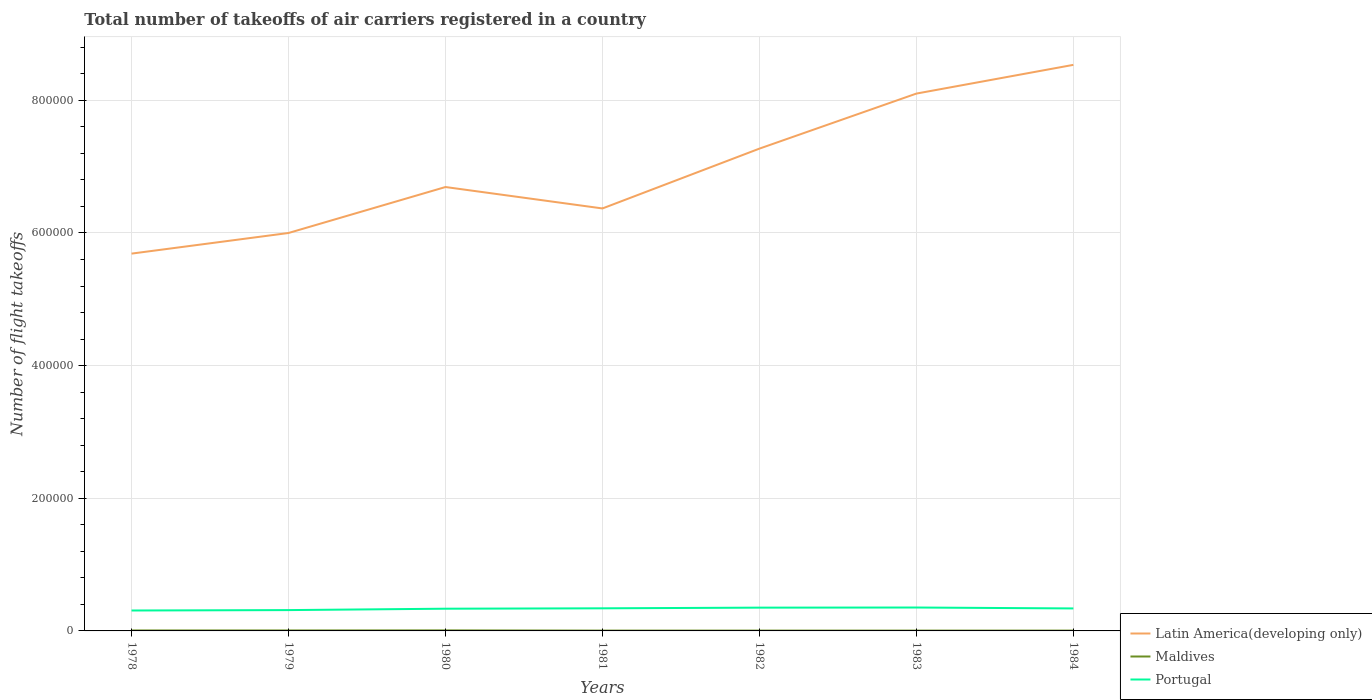Is the number of lines equal to the number of legend labels?
Offer a very short reply. Yes. What is the total total number of flight takeoffs in Portugal in the graph?
Offer a terse response. -600. What is the difference between the highest and the second highest total number of flight takeoffs in Latin America(developing only)?
Provide a short and direct response. 2.85e+05. How many lines are there?
Your answer should be compact. 3. How many years are there in the graph?
Give a very brief answer. 7. What is the difference between two consecutive major ticks on the Y-axis?
Provide a succinct answer. 2.00e+05. Does the graph contain any zero values?
Offer a terse response. No. Does the graph contain grids?
Provide a short and direct response. Yes. Where does the legend appear in the graph?
Provide a short and direct response. Bottom right. What is the title of the graph?
Ensure brevity in your answer.  Total number of takeoffs of air carriers registered in a country. Does "Ukraine" appear as one of the legend labels in the graph?
Your answer should be compact. No. What is the label or title of the X-axis?
Make the answer very short. Years. What is the label or title of the Y-axis?
Offer a terse response. Number of flight takeoffs. What is the Number of flight takeoffs in Latin America(developing only) in 1978?
Keep it short and to the point. 5.69e+05. What is the Number of flight takeoffs of Maldives in 1978?
Ensure brevity in your answer.  700. What is the Number of flight takeoffs of Portugal in 1978?
Keep it short and to the point. 3.08e+04. What is the Number of flight takeoffs in Latin America(developing only) in 1979?
Provide a short and direct response. 6.00e+05. What is the Number of flight takeoffs in Maldives in 1979?
Give a very brief answer. 700. What is the Number of flight takeoffs of Portugal in 1979?
Provide a succinct answer. 3.14e+04. What is the Number of flight takeoffs of Latin America(developing only) in 1980?
Your response must be concise. 6.69e+05. What is the Number of flight takeoffs in Maldives in 1980?
Offer a very short reply. 800. What is the Number of flight takeoffs in Portugal in 1980?
Your answer should be very brief. 3.35e+04. What is the Number of flight takeoffs in Latin America(developing only) in 1981?
Your response must be concise. 6.37e+05. What is the Number of flight takeoffs of Portugal in 1981?
Keep it short and to the point. 3.41e+04. What is the Number of flight takeoffs in Latin America(developing only) in 1982?
Your answer should be very brief. 7.27e+05. What is the Number of flight takeoffs in Portugal in 1982?
Offer a terse response. 3.51e+04. What is the Number of flight takeoffs in Latin America(developing only) in 1983?
Give a very brief answer. 8.10e+05. What is the Number of flight takeoffs of Portugal in 1983?
Make the answer very short. 3.53e+04. What is the Number of flight takeoffs in Latin America(developing only) in 1984?
Provide a short and direct response. 8.54e+05. What is the Number of flight takeoffs in Maldives in 1984?
Provide a succinct answer. 500. What is the Number of flight takeoffs in Portugal in 1984?
Offer a very short reply. 3.39e+04. Across all years, what is the maximum Number of flight takeoffs in Latin America(developing only)?
Your answer should be compact. 8.54e+05. Across all years, what is the maximum Number of flight takeoffs of Maldives?
Ensure brevity in your answer.  800. Across all years, what is the maximum Number of flight takeoffs of Portugal?
Provide a short and direct response. 3.53e+04. Across all years, what is the minimum Number of flight takeoffs of Latin America(developing only)?
Offer a very short reply. 5.69e+05. Across all years, what is the minimum Number of flight takeoffs of Portugal?
Your answer should be very brief. 3.08e+04. What is the total Number of flight takeoffs in Latin America(developing only) in the graph?
Your answer should be very brief. 4.87e+06. What is the total Number of flight takeoffs of Maldives in the graph?
Your answer should be very brief. 4200. What is the total Number of flight takeoffs of Portugal in the graph?
Offer a very short reply. 2.34e+05. What is the difference between the Number of flight takeoffs in Latin America(developing only) in 1978 and that in 1979?
Ensure brevity in your answer.  -3.11e+04. What is the difference between the Number of flight takeoffs in Portugal in 1978 and that in 1979?
Your answer should be compact. -600. What is the difference between the Number of flight takeoffs in Latin America(developing only) in 1978 and that in 1980?
Make the answer very short. -1.00e+05. What is the difference between the Number of flight takeoffs of Maldives in 1978 and that in 1980?
Provide a short and direct response. -100. What is the difference between the Number of flight takeoffs in Portugal in 1978 and that in 1980?
Offer a very short reply. -2700. What is the difference between the Number of flight takeoffs in Latin America(developing only) in 1978 and that in 1981?
Your answer should be very brief. -6.81e+04. What is the difference between the Number of flight takeoffs of Portugal in 1978 and that in 1981?
Give a very brief answer. -3300. What is the difference between the Number of flight takeoffs in Latin America(developing only) in 1978 and that in 1982?
Offer a very short reply. -1.58e+05. What is the difference between the Number of flight takeoffs in Maldives in 1978 and that in 1982?
Make the answer very short. 200. What is the difference between the Number of flight takeoffs of Portugal in 1978 and that in 1982?
Ensure brevity in your answer.  -4300. What is the difference between the Number of flight takeoffs in Latin America(developing only) in 1978 and that in 1983?
Your answer should be compact. -2.41e+05. What is the difference between the Number of flight takeoffs in Maldives in 1978 and that in 1983?
Give a very brief answer. 200. What is the difference between the Number of flight takeoffs of Portugal in 1978 and that in 1983?
Make the answer very short. -4500. What is the difference between the Number of flight takeoffs of Latin America(developing only) in 1978 and that in 1984?
Offer a very short reply. -2.85e+05. What is the difference between the Number of flight takeoffs of Portugal in 1978 and that in 1984?
Provide a short and direct response. -3100. What is the difference between the Number of flight takeoffs of Latin America(developing only) in 1979 and that in 1980?
Give a very brief answer. -6.93e+04. What is the difference between the Number of flight takeoffs in Maldives in 1979 and that in 1980?
Offer a very short reply. -100. What is the difference between the Number of flight takeoffs of Portugal in 1979 and that in 1980?
Give a very brief answer. -2100. What is the difference between the Number of flight takeoffs of Latin America(developing only) in 1979 and that in 1981?
Provide a succinct answer. -3.70e+04. What is the difference between the Number of flight takeoffs of Portugal in 1979 and that in 1981?
Your response must be concise. -2700. What is the difference between the Number of flight takeoffs in Latin America(developing only) in 1979 and that in 1982?
Ensure brevity in your answer.  -1.27e+05. What is the difference between the Number of flight takeoffs of Portugal in 1979 and that in 1982?
Your answer should be very brief. -3700. What is the difference between the Number of flight takeoffs of Latin America(developing only) in 1979 and that in 1983?
Make the answer very short. -2.10e+05. What is the difference between the Number of flight takeoffs of Portugal in 1979 and that in 1983?
Give a very brief answer. -3900. What is the difference between the Number of flight takeoffs of Latin America(developing only) in 1979 and that in 1984?
Your response must be concise. -2.54e+05. What is the difference between the Number of flight takeoffs of Portugal in 1979 and that in 1984?
Ensure brevity in your answer.  -2500. What is the difference between the Number of flight takeoffs in Latin America(developing only) in 1980 and that in 1981?
Provide a succinct answer. 3.23e+04. What is the difference between the Number of flight takeoffs of Maldives in 1980 and that in 1981?
Offer a very short reply. 300. What is the difference between the Number of flight takeoffs of Portugal in 1980 and that in 1981?
Provide a succinct answer. -600. What is the difference between the Number of flight takeoffs of Latin America(developing only) in 1980 and that in 1982?
Your answer should be very brief. -5.79e+04. What is the difference between the Number of flight takeoffs in Maldives in 1980 and that in 1982?
Provide a short and direct response. 300. What is the difference between the Number of flight takeoffs of Portugal in 1980 and that in 1982?
Offer a terse response. -1600. What is the difference between the Number of flight takeoffs in Latin America(developing only) in 1980 and that in 1983?
Offer a terse response. -1.41e+05. What is the difference between the Number of flight takeoffs in Maldives in 1980 and that in 1983?
Give a very brief answer. 300. What is the difference between the Number of flight takeoffs in Portugal in 1980 and that in 1983?
Offer a terse response. -1800. What is the difference between the Number of flight takeoffs of Latin America(developing only) in 1980 and that in 1984?
Provide a succinct answer. -1.84e+05. What is the difference between the Number of flight takeoffs in Maldives in 1980 and that in 1984?
Make the answer very short. 300. What is the difference between the Number of flight takeoffs of Portugal in 1980 and that in 1984?
Give a very brief answer. -400. What is the difference between the Number of flight takeoffs in Latin America(developing only) in 1981 and that in 1982?
Provide a succinct answer. -9.02e+04. What is the difference between the Number of flight takeoffs of Portugal in 1981 and that in 1982?
Your response must be concise. -1000. What is the difference between the Number of flight takeoffs of Latin America(developing only) in 1981 and that in 1983?
Ensure brevity in your answer.  -1.73e+05. What is the difference between the Number of flight takeoffs in Maldives in 1981 and that in 1983?
Your answer should be very brief. 0. What is the difference between the Number of flight takeoffs of Portugal in 1981 and that in 1983?
Provide a short and direct response. -1200. What is the difference between the Number of flight takeoffs of Latin America(developing only) in 1981 and that in 1984?
Provide a short and direct response. -2.16e+05. What is the difference between the Number of flight takeoffs of Maldives in 1981 and that in 1984?
Ensure brevity in your answer.  0. What is the difference between the Number of flight takeoffs of Latin America(developing only) in 1982 and that in 1983?
Your answer should be very brief. -8.30e+04. What is the difference between the Number of flight takeoffs of Portugal in 1982 and that in 1983?
Keep it short and to the point. -200. What is the difference between the Number of flight takeoffs in Latin America(developing only) in 1982 and that in 1984?
Make the answer very short. -1.26e+05. What is the difference between the Number of flight takeoffs in Portugal in 1982 and that in 1984?
Ensure brevity in your answer.  1200. What is the difference between the Number of flight takeoffs in Latin America(developing only) in 1983 and that in 1984?
Your answer should be compact. -4.33e+04. What is the difference between the Number of flight takeoffs in Maldives in 1983 and that in 1984?
Offer a terse response. 0. What is the difference between the Number of flight takeoffs in Portugal in 1983 and that in 1984?
Your response must be concise. 1400. What is the difference between the Number of flight takeoffs in Latin America(developing only) in 1978 and the Number of flight takeoffs in Maldives in 1979?
Offer a terse response. 5.68e+05. What is the difference between the Number of flight takeoffs of Latin America(developing only) in 1978 and the Number of flight takeoffs of Portugal in 1979?
Your response must be concise. 5.38e+05. What is the difference between the Number of flight takeoffs of Maldives in 1978 and the Number of flight takeoffs of Portugal in 1979?
Provide a short and direct response. -3.07e+04. What is the difference between the Number of flight takeoffs in Latin America(developing only) in 1978 and the Number of flight takeoffs in Maldives in 1980?
Give a very brief answer. 5.68e+05. What is the difference between the Number of flight takeoffs in Latin America(developing only) in 1978 and the Number of flight takeoffs in Portugal in 1980?
Your answer should be very brief. 5.35e+05. What is the difference between the Number of flight takeoffs in Maldives in 1978 and the Number of flight takeoffs in Portugal in 1980?
Your answer should be compact. -3.28e+04. What is the difference between the Number of flight takeoffs in Latin America(developing only) in 1978 and the Number of flight takeoffs in Maldives in 1981?
Give a very brief answer. 5.68e+05. What is the difference between the Number of flight takeoffs in Latin America(developing only) in 1978 and the Number of flight takeoffs in Portugal in 1981?
Provide a short and direct response. 5.35e+05. What is the difference between the Number of flight takeoffs in Maldives in 1978 and the Number of flight takeoffs in Portugal in 1981?
Provide a short and direct response. -3.34e+04. What is the difference between the Number of flight takeoffs in Latin America(developing only) in 1978 and the Number of flight takeoffs in Maldives in 1982?
Provide a succinct answer. 5.68e+05. What is the difference between the Number of flight takeoffs in Latin America(developing only) in 1978 and the Number of flight takeoffs in Portugal in 1982?
Provide a succinct answer. 5.34e+05. What is the difference between the Number of flight takeoffs in Maldives in 1978 and the Number of flight takeoffs in Portugal in 1982?
Your answer should be very brief. -3.44e+04. What is the difference between the Number of flight takeoffs of Latin America(developing only) in 1978 and the Number of flight takeoffs of Maldives in 1983?
Ensure brevity in your answer.  5.68e+05. What is the difference between the Number of flight takeoffs in Latin America(developing only) in 1978 and the Number of flight takeoffs in Portugal in 1983?
Offer a very short reply. 5.34e+05. What is the difference between the Number of flight takeoffs in Maldives in 1978 and the Number of flight takeoffs in Portugal in 1983?
Your answer should be very brief. -3.46e+04. What is the difference between the Number of flight takeoffs in Latin America(developing only) in 1978 and the Number of flight takeoffs in Maldives in 1984?
Make the answer very short. 5.68e+05. What is the difference between the Number of flight takeoffs of Latin America(developing only) in 1978 and the Number of flight takeoffs of Portugal in 1984?
Your answer should be compact. 5.35e+05. What is the difference between the Number of flight takeoffs of Maldives in 1978 and the Number of flight takeoffs of Portugal in 1984?
Your answer should be very brief. -3.32e+04. What is the difference between the Number of flight takeoffs in Latin America(developing only) in 1979 and the Number of flight takeoffs in Maldives in 1980?
Give a very brief answer. 5.99e+05. What is the difference between the Number of flight takeoffs in Latin America(developing only) in 1979 and the Number of flight takeoffs in Portugal in 1980?
Offer a very short reply. 5.66e+05. What is the difference between the Number of flight takeoffs in Maldives in 1979 and the Number of flight takeoffs in Portugal in 1980?
Your answer should be very brief. -3.28e+04. What is the difference between the Number of flight takeoffs in Latin America(developing only) in 1979 and the Number of flight takeoffs in Maldives in 1981?
Make the answer very short. 6.00e+05. What is the difference between the Number of flight takeoffs in Latin America(developing only) in 1979 and the Number of flight takeoffs in Portugal in 1981?
Your answer should be compact. 5.66e+05. What is the difference between the Number of flight takeoffs of Maldives in 1979 and the Number of flight takeoffs of Portugal in 1981?
Give a very brief answer. -3.34e+04. What is the difference between the Number of flight takeoffs of Latin America(developing only) in 1979 and the Number of flight takeoffs of Maldives in 1982?
Offer a terse response. 6.00e+05. What is the difference between the Number of flight takeoffs in Latin America(developing only) in 1979 and the Number of flight takeoffs in Portugal in 1982?
Your answer should be compact. 5.65e+05. What is the difference between the Number of flight takeoffs of Maldives in 1979 and the Number of flight takeoffs of Portugal in 1982?
Offer a terse response. -3.44e+04. What is the difference between the Number of flight takeoffs of Latin America(developing only) in 1979 and the Number of flight takeoffs of Maldives in 1983?
Make the answer very short. 6.00e+05. What is the difference between the Number of flight takeoffs of Latin America(developing only) in 1979 and the Number of flight takeoffs of Portugal in 1983?
Your response must be concise. 5.65e+05. What is the difference between the Number of flight takeoffs in Maldives in 1979 and the Number of flight takeoffs in Portugal in 1983?
Provide a short and direct response. -3.46e+04. What is the difference between the Number of flight takeoffs in Latin America(developing only) in 1979 and the Number of flight takeoffs in Maldives in 1984?
Provide a succinct answer. 6.00e+05. What is the difference between the Number of flight takeoffs in Latin America(developing only) in 1979 and the Number of flight takeoffs in Portugal in 1984?
Ensure brevity in your answer.  5.66e+05. What is the difference between the Number of flight takeoffs of Maldives in 1979 and the Number of flight takeoffs of Portugal in 1984?
Give a very brief answer. -3.32e+04. What is the difference between the Number of flight takeoffs of Latin America(developing only) in 1980 and the Number of flight takeoffs of Maldives in 1981?
Your response must be concise. 6.69e+05. What is the difference between the Number of flight takeoffs of Latin America(developing only) in 1980 and the Number of flight takeoffs of Portugal in 1981?
Keep it short and to the point. 6.35e+05. What is the difference between the Number of flight takeoffs of Maldives in 1980 and the Number of flight takeoffs of Portugal in 1981?
Your answer should be compact. -3.33e+04. What is the difference between the Number of flight takeoffs in Latin America(developing only) in 1980 and the Number of flight takeoffs in Maldives in 1982?
Ensure brevity in your answer.  6.69e+05. What is the difference between the Number of flight takeoffs in Latin America(developing only) in 1980 and the Number of flight takeoffs in Portugal in 1982?
Give a very brief answer. 6.34e+05. What is the difference between the Number of flight takeoffs in Maldives in 1980 and the Number of flight takeoffs in Portugal in 1982?
Offer a very short reply. -3.43e+04. What is the difference between the Number of flight takeoffs in Latin America(developing only) in 1980 and the Number of flight takeoffs in Maldives in 1983?
Give a very brief answer. 6.69e+05. What is the difference between the Number of flight takeoffs in Latin America(developing only) in 1980 and the Number of flight takeoffs in Portugal in 1983?
Make the answer very short. 6.34e+05. What is the difference between the Number of flight takeoffs of Maldives in 1980 and the Number of flight takeoffs of Portugal in 1983?
Provide a succinct answer. -3.45e+04. What is the difference between the Number of flight takeoffs of Latin America(developing only) in 1980 and the Number of flight takeoffs of Maldives in 1984?
Your response must be concise. 6.69e+05. What is the difference between the Number of flight takeoffs in Latin America(developing only) in 1980 and the Number of flight takeoffs in Portugal in 1984?
Your answer should be very brief. 6.35e+05. What is the difference between the Number of flight takeoffs in Maldives in 1980 and the Number of flight takeoffs in Portugal in 1984?
Your answer should be very brief. -3.31e+04. What is the difference between the Number of flight takeoffs of Latin America(developing only) in 1981 and the Number of flight takeoffs of Maldives in 1982?
Your answer should be very brief. 6.36e+05. What is the difference between the Number of flight takeoffs of Latin America(developing only) in 1981 and the Number of flight takeoffs of Portugal in 1982?
Your answer should be compact. 6.02e+05. What is the difference between the Number of flight takeoffs of Maldives in 1981 and the Number of flight takeoffs of Portugal in 1982?
Offer a very short reply. -3.46e+04. What is the difference between the Number of flight takeoffs in Latin America(developing only) in 1981 and the Number of flight takeoffs in Maldives in 1983?
Ensure brevity in your answer.  6.36e+05. What is the difference between the Number of flight takeoffs of Latin America(developing only) in 1981 and the Number of flight takeoffs of Portugal in 1983?
Give a very brief answer. 6.02e+05. What is the difference between the Number of flight takeoffs in Maldives in 1981 and the Number of flight takeoffs in Portugal in 1983?
Make the answer very short. -3.48e+04. What is the difference between the Number of flight takeoffs of Latin America(developing only) in 1981 and the Number of flight takeoffs of Maldives in 1984?
Keep it short and to the point. 6.36e+05. What is the difference between the Number of flight takeoffs in Latin America(developing only) in 1981 and the Number of flight takeoffs in Portugal in 1984?
Your response must be concise. 6.03e+05. What is the difference between the Number of flight takeoffs of Maldives in 1981 and the Number of flight takeoffs of Portugal in 1984?
Keep it short and to the point. -3.34e+04. What is the difference between the Number of flight takeoffs in Latin America(developing only) in 1982 and the Number of flight takeoffs in Maldives in 1983?
Keep it short and to the point. 7.27e+05. What is the difference between the Number of flight takeoffs in Latin America(developing only) in 1982 and the Number of flight takeoffs in Portugal in 1983?
Offer a very short reply. 6.92e+05. What is the difference between the Number of flight takeoffs in Maldives in 1982 and the Number of flight takeoffs in Portugal in 1983?
Provide a succinct answer. -3.48e+04. What is the difference between the Number of flight takeoffs in Latin America(developing only) in 1982 and the Number of flight takeoffs in Maldives in 1984?
Ensure brevity in your answer.  7.27e+05. What is the difference between the Number of flight takeoffs of Latin America(developing only) in 1982 and the Number of flight takeoffs of Portugal in 1984?
Your answer should be very brief. 6.93e+05. What is the difference between the Number of flight takeoffs in Maldives in 1982 and the Number of flight takeoffs in Portugal in 1984?
Provide a short and direct response. -3.34e+04. What is the difference between the Number of flight takeoffs in Latin America(developing only) in 1983 and the Number of flight takeoffs in Maldives in 1984?
Make the answer very short. 8.10e+05. What is the difference between the Number of flight takeoffs in Latin America(developing only) in 1983 and the Number of flight takeoffs in Portugal in 1984?
Your response must be concise. 7.76e+05. What is the difference between the Number of flight takeoffs of Maldives in 1983 and the Number of flight takeoffs of Portugal in 1984?
Give a very brief answer. -3.34e+04. What is the average Number of flight takeoffs in Latin America(developing only) per year?
Ensure brevity in your answer.  6.95e+05. What is the average Number of flight takeoffs in Maldives per year?
Offer a very short reply. 600. What is the average Number of flight takeoffs in Portugal per year?
Provide a short and direct response. 3.34e+04. In the year 1978, what is the difference between the Number of flight takeoffs of Latin America(developing only) and Number of flight takeoffs of Maldives?
Your answer should be very brief. 5.68e+05. In the year 1978, what is the difference between the Number of flight takeoffs in Latin America(developing only) and Number of flight takeoffs in Portugal?
Ensure brevity in your answer.  5.38e+05. In the year 1978, what is the difference between the Number of flight takeoffs of Maldives and Number of flight takeoffs of Portugal?
Provide a short and direct response. -3.01e+04. In the year 1979, what is the difference between the Number of flight takeoffs of Latin America(developing only) and Number of flight takeoffs of Maldives?
Provide a succinct answer. 5.99e+05. In the year 1979, what is the difference between the Number of flight takeoffs of Latin America(developing only) and Number of flight takeoffs of Portugal?
Keep it short and to the point. 5.69e+05. In the year 1979, what is the difference between the Number of flight takeoffs of Maldives and Number of flight takeoffs of Portugal?
Give a very brief answer. -3.07e+04. In the year 1980, what is the difference between the Number of flight takeoffs in Latin America(developing only) and Number of flight takeoffs in Maldives?
Provide a succinct answer. 6.68e+05. In the year 1980, what is the difference between the Number of flight takeoffs in Latin America(developing only) and Number of flight takeoffs in Portugal?
Provide a succinct answer. 6.36e+05. In the year 1980, what is the difference between the Number of flight takeoffs of Maldives and Number of flight takeoffs of Portugal?
Offer a very short reply. -3.27e+04. In the year 1981, what is the difference between the Number of flight takeoffs in Latin America(developing only) and Number of flight takeoffs in Maldives?
Offer a terse response. 6.36e+05. In the year 1981, what is the difference between the Number of flight takeoffs of Latin America(developing only) and Number of flight takeoffs of Portugal?
Keep it short and to the point. 6.03e+05. In the year 1981, what is the difference between the Number of flight takeoffs in Maldives and Number of flight takeoffs in Portugal?
Offer a terse response. -3.36e+04. In the year 1982, what is the difference between the Number of flight takeoffs in Latin America(developing only) and Number of flight takeoffs in Maldives?
Offer a terse response. 7.27e+05. In the year 1982, what is the difference between the Number of flight takeoffs of Latin America(developing only) and Number of flight takeoffs of Portugal?
Your response must be concise. 6.92e+05. In the year 1982, what is the difference between the Number of flight takeoffs of Maldives and Number of flight takeoffs of Portugal?
Keep it short and to the point. -3.46e+04. In the year 1983, what is the difference between the Number of flight takeoffs of Latin America(developing only) and Number of flight takeoffs of Maldives?
Keep it short and to the point. 8.10e+05. In the year 1983, what is the difference between the Number of flight takeoffs of Latin America(developing only) and Number of flight takeoffs of Portugal?
Your answer should be compact. 7.75e+05. In the year 1983, what is the difference between the Number of flight takeoffs in Maldives and Number of flight takeoffs in Portugal?
Your answer should be compact. -3.48e+04. In the year 1984, what is the difference between the Number of flight takeoffs in Latin America(developing only) and Number of flight takeoffs in Maldives?
Offer a very short reply. 8.53e+05. In the year 1984, what is the difference between the Number of flight takeoffs in Latin America(developing only) and Number of flight takeoffs in Portugal?
Make the answer very short. 8.20e+05. In the year 1984, what is the difference between the Number of flight takeoffs of Maldives and Number of flight takeoffs of Portugal?
Offer a very short reply. -3.34e+04. What is the ratio of the Number of flight takeoffs of Latin America(developing only) in 1978 to that in 1979?
Keep it short and to the point. 0.95. What is the ratio of the Number of flight takeoffs of Maldives in 1978 to that in 1979?
Your answer should be compact. 1. What is the ratio of the Number of flight takeoffs in Portugal in 1978 to that in 1979?
Your answer should be very brief. 0.98. What is the ratio of the Number of flight takeoffs of Latin America(developing only) in 1978 to that in 1980?
Make the answer very short. 0.85. What is the ratio of the Number of flight takeoffs in Maldives in 1978 to that in 1980?
Provide a succinct answer. 0.88. What is the ratio of the Number of flight takeoffs in Portugal in 1978 to that in 1980?
Your response must be concise. 0.92. What is the ratio of the Number of flight takeoffs of Latin America(developing only) in 1978 to that in 1981?
Your answer should be compact. 0.89. What is the ratio of the Number of flight takeoffs in Portugal in 1978 to that in 1981?
Provide a succinct answer. 0.9. What is the ratio of the Number of flight takeoffs of Latin America(developing only) in 1978 to that in 1982?
Your answer should be compact. 0.78. What is the ratio of the Number of flight takeoffs of Portugal in 1978 to that in 1982?
Your response must be concise. 0.88. What is the ratio of the Number of flight takeoffs in Latin America(developing only) in 1978 to that in 1983?
Provide a succinct answer. 0.7. What is the ratio of the Number of flight takeoffs of Portugal in 1978 to that in 1983?
Keep it short and to the point. 0.87. What is the ratio of the Number of flight takeoffs in Latin America(developing only) in 1978 to that in 1984?
Your response must be concise. 0.67. What is the ratio of the Number of flight takeoffs in Portugal in 1978 to that in 1984?
Ensure brevity in your answer.  0.91. What is the ratio of the Number of flight takeoffs in Latin America(developing only) in 1979 to that in 1980?
Your response must be concise. 0.9. What is the ratio of the Number of flight takeoffs in Portugal in 1979 to that in 1980?
Offer a terse response. 0.94. What is the ratio of the Number of flight takeoffs in Latin America(developing only) in 1979 to that in 1981?
Your answer should be compact. 0.94. What is the ratio of the Number of flight takeoffs in Portugal in 1979 to that in 1981?
Ensure brevity in your answer.  0.92. What is the ratio of the Number of flight takeoffs of Latin America(developing only) in 1979 to that in 1982?
Keep it short and to the point. 0.83. What is the ratio of the Number of flight takeoffs in Maldives in 1979 to that in 1982?
Ensure brevity in your answer.  1.4. What is the ratio of the Number of flight takeoffs in Portugal in 1979 to that in 1982?
Your answer should be very brief. 0.89. What is the ratio of the Number of flight takeoffs in Latin America(developing only) in 1979 to that in 1983?
Offer a very short reply. 0.74. What is the ratio of the Number of flight takeoffs of Portugal in 1979 to that in 1983?
Your answer should be very brief. 0.89. What is the ratio of the Number of flight takeoffs of Latin America(developing only) in 1979 to that in 1984?
Offer a very short reply. 0.7. What is the ratio of the Number of flight takeoffs of Maldives in 1979 to that in 1984?
Provide a short and direct response. 1.4. What is the ratio of the Number of flight takeoffs of Portugal in 1979 to that in 1984?
Your answer should be very brief. 0.93. What is the ratio of the Number of flight takeoffs of Latin America(developing only) in 1980 to that in 1981?
Make the answer very short. 1.05. What is the ratio of the Number of flight takeoffs of Maldives in 1980 to that in 1981?
Provide a short and direct response. 1.6. What is the ratio of the Number of flight takeoffs in Portugal in 1980 to that in 1981?
Your response must be concise. 0.98. What is the ratio of the Number of flight takeoffs of Latin America(developing only) in 1980 to that in 1982?
Keep it short and to the point. 0.92. What is the ratio of the Number of flight takeoffs of Portugal in 1980 to that in 1982?
Your answer should be very brief. 0.95. What is the ratio of the Number of flight takeoffs in Latin America(developing only) in 1980 to that in 1983?
Provide a succinct answer. 0.83. What is the ratio of the Number of flight takeoffs of Maldives in 1980 to that in 1983?
Offer a very short reply. 1.6. What is the ratio of the Number of flight takeoffs of Portugal in 1980 to that in 1983?
Make the answer very short. 0.95. What is the ratio of the Number of flight takeoffs of Latin America(developing only) in 1980 to that in 1984?
Your response must be concise. 0.78. What is the ratio of the Number of flight takeoffs of Maldives in 1980 to that in 1984?
Your response must be concise. 1.6. What is the ratio of the Number of flight takeoffs in Portugal in 1980 to that in 1984?
Provide a short and direct response. 0.99. What is the ratio of the Number of flight takeoffs of Latin America(developing only) in 1981 to that in 1982?
Your answer should be very brief. 0.88. What is the ratio of the Number of flight takeoffs of Portugal in 1981 to that in 1982?
Ensure brevity in your answer.  0.97. What is the ratio of the Number of flight takeoffs of Latin America(developing only) in 1981 to that in 1983?
Ensure brevity in your answer.  0.79. What is the ratio of the Number of flight takeoffs in Latin America(developing only) in 1981 to that in 1984?
Your response must be concise. 0.75. What is the ratio of the Number of flight takeoffs in Portugal in 1981 to that in 1984?
Keep it short and to the point. 1.01. What is the ratio of the Number of flight takeoffs in Latin America(developing only) in 1982 to that in 1983?
Keep it short and to the point. 0.9. What is the ratio of the Number of flight takeoffs of Portugal in 1982 to that in 1983?
Offer a very short reply. 0.99. What is the ratio of the Number of flight takeoffs of Latin America(developing only) in 1982 to that in 1984?
Ensure brevity in your answer.  0.85. What is the ratio of the Number of flight takeoffs of Portugal in 1982 to that in 1984?
Offer a terse response. 1.04. What is the ratio of the Number of flight takeoffs of Latin America(developing only) in 1983 to that in 1984?
Offer a terse response. 0.95. What is the ratio of the Number of flight takeoffs in Portugal in 1983 to that in 1984?
Your answer should be compact. 1.04. What is the difference between the highest and the second highest Number of flight takeoffs of Latin America(developing only)?
Offer a terse response. 4.33e+04. What is the difference between the highest and the second highest Number of flight takeoffs in Maldives?
Keep it short and to the point. 100. What is the difference between the highest and the lowest Number of flight takeoffs in Latin America(developing only)?
Ensure brevity in your answer.  2.85e+05. What is the difference between the highest and the lowest Number of flight takeoffs in Maldives?
Make the answer very short. 300. What is the difference between the highest and the lowest Number of flight takeoffs of Portugal?
Make the answer very short. 4500. 